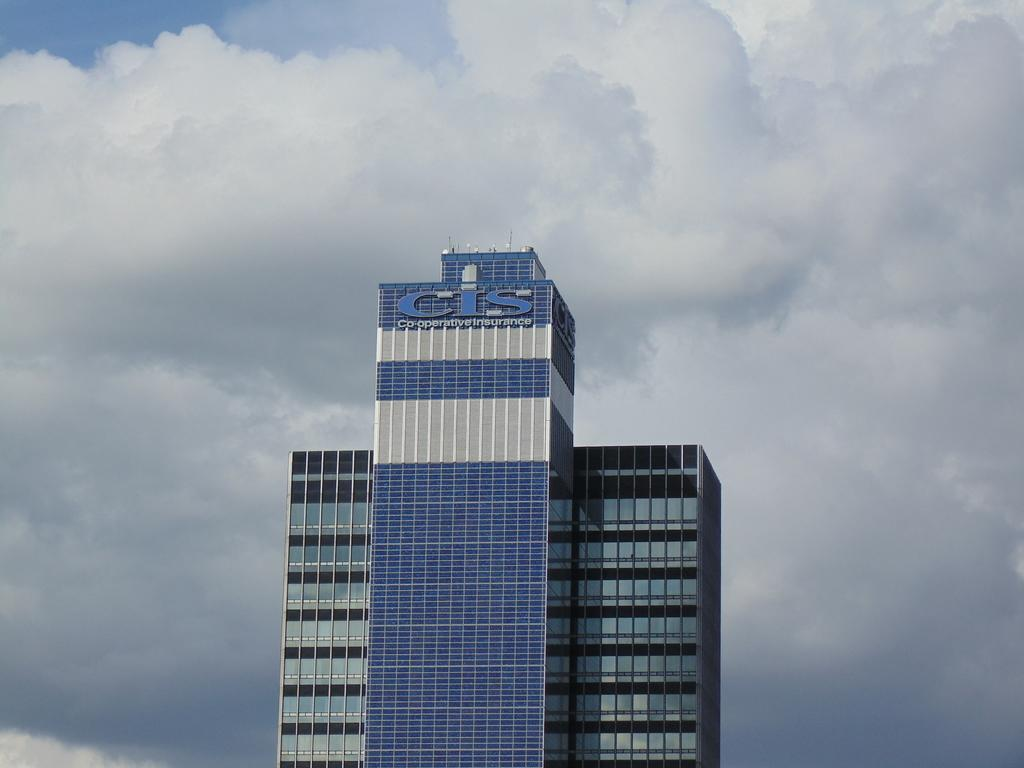What type of structures can be seen in the image? There are buildings in the image. Are there any textual elements in the image? Yes, there are words written in the image. What can be seen in the background of the image? There are clouds visible in the background of the image. What type of bag is being carried by the authority figure in the image? There is no authority figure or bag present in the image. How does the knee of the person in the image look? There is no person or knee visible in the image. 